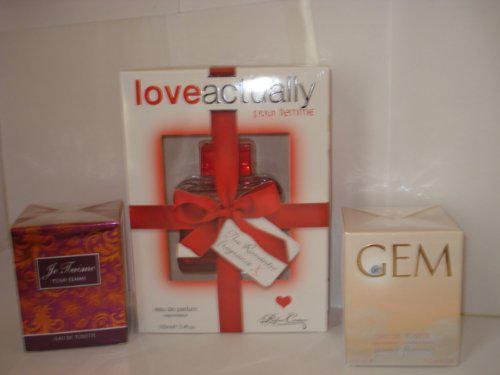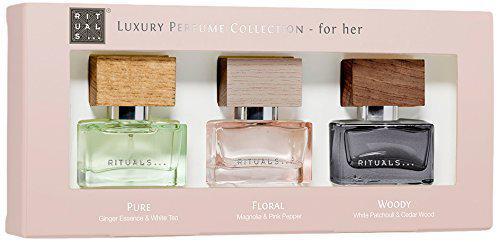The first image is the image on the left, the second image is the image on the right. Given the left and right images, does the statement "One box contains multiple items." hold true? Answer yes or no. Yes. 